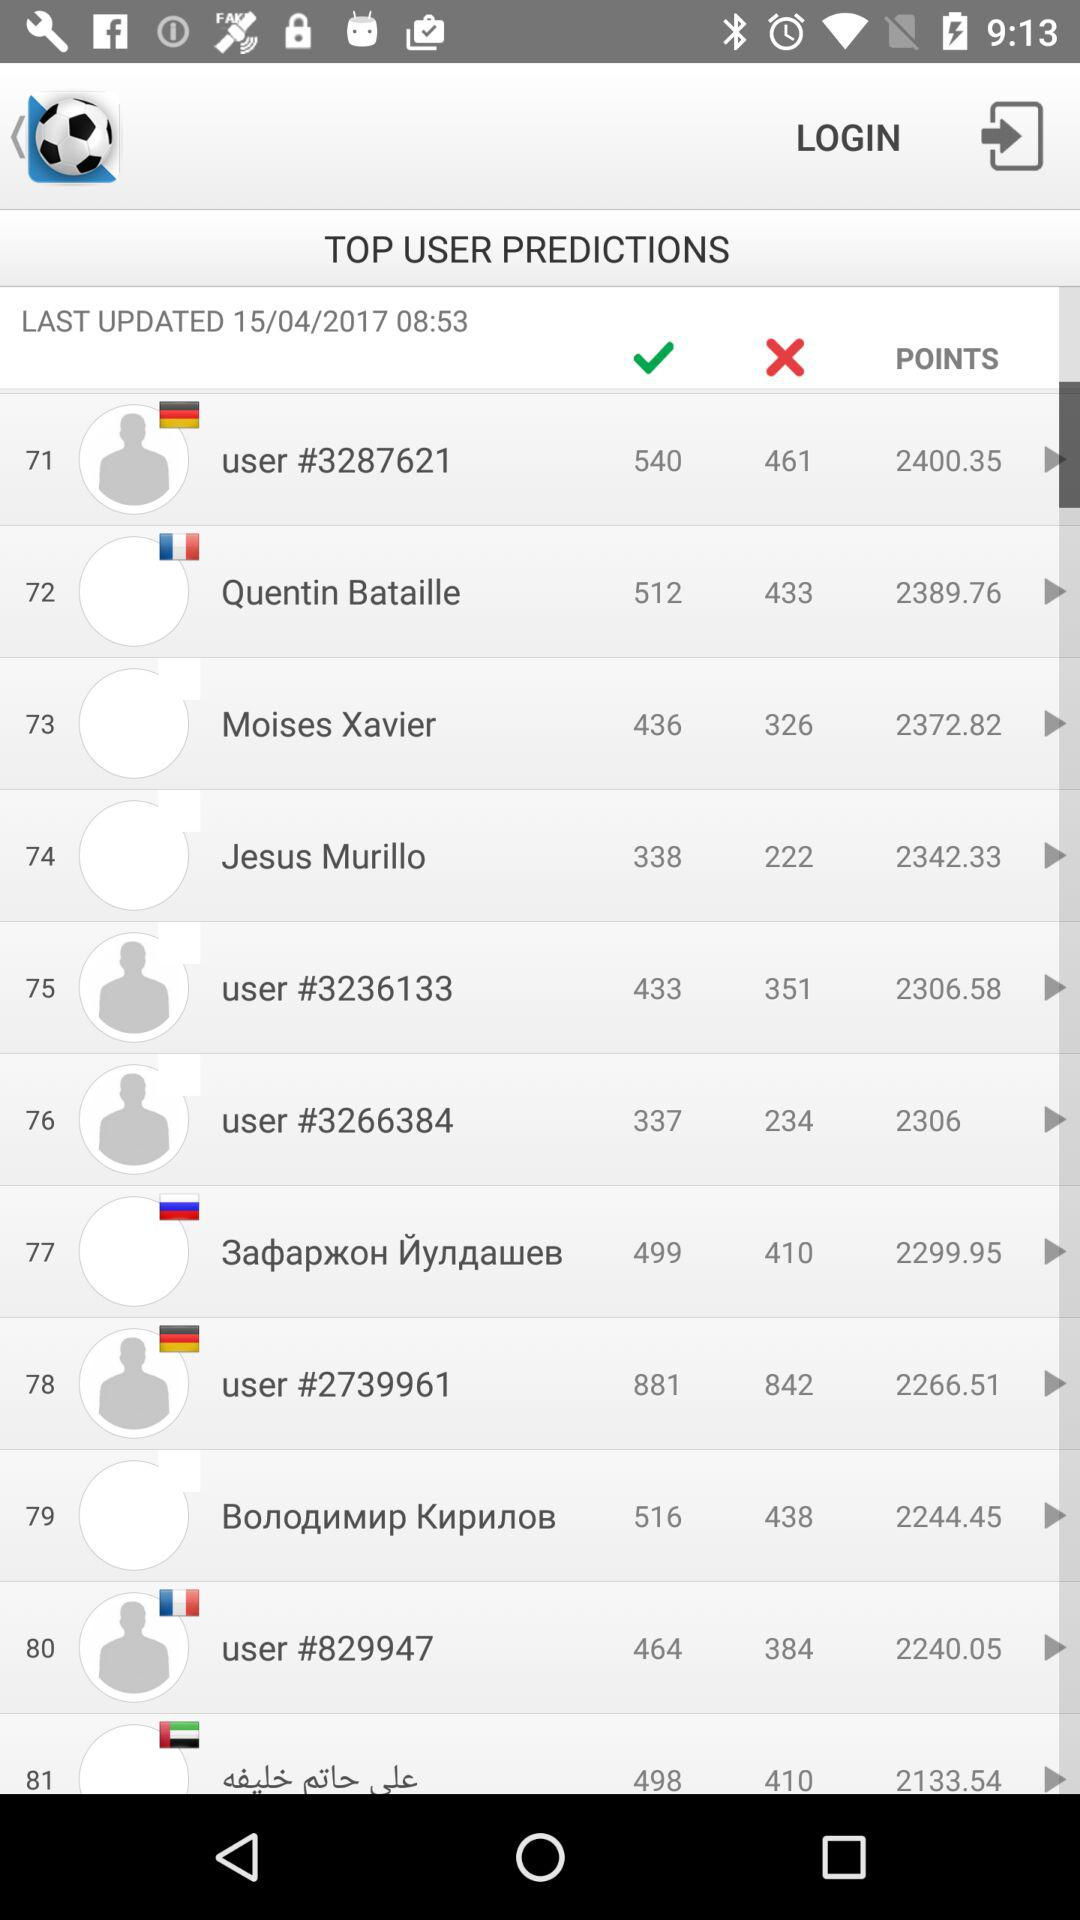How many points does the user with the lowest point total have?
Answer the question using a single word or phrase. 2133.54 